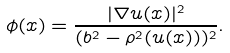<formula> <loc_0><loc_0><loc_500><loc_500>\phi ( x ) = \frac { | \nabla u ( x ) | ^ { 2 } } { ( b ^ { 2 } - \rho ^ { 2 } ( u ( x ) ) ) ^ { 2 } } .</formula> 